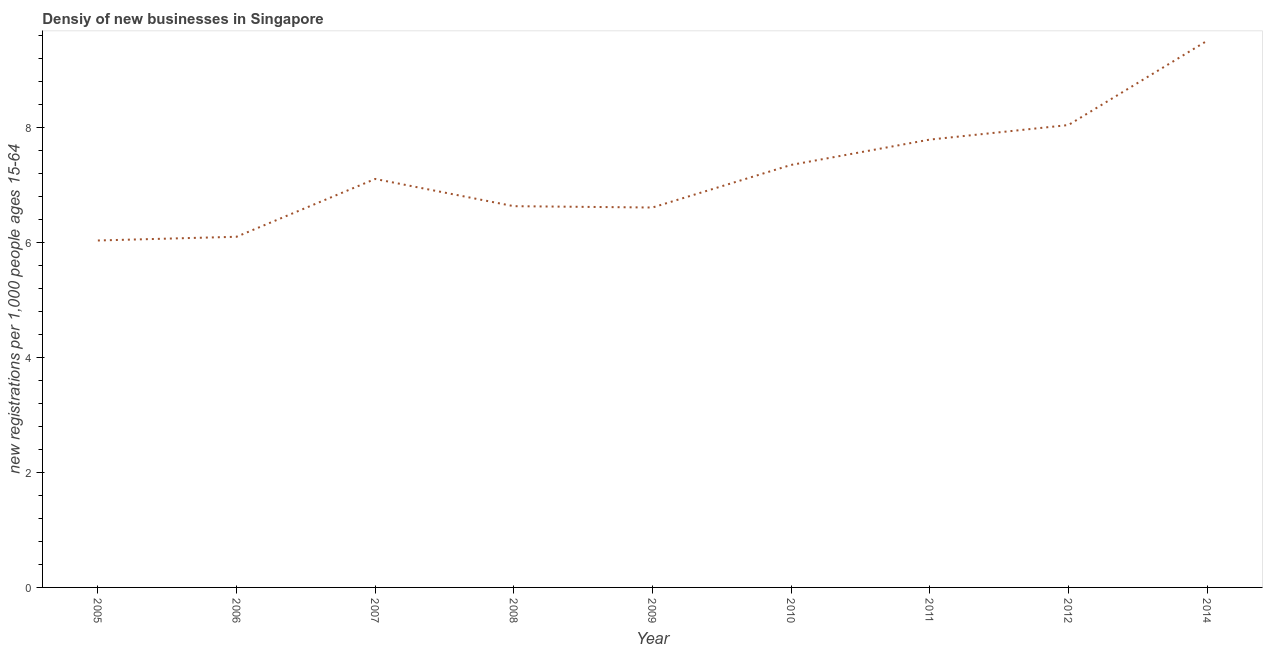What is the density of new business in 2012?
Provide a short and direct response. 8.04. Across all years, what is the maximum density of new business?
Provide a short and direct response. 9.51. Across all years, what is the minimum density of new business?
Offer a very short reply. 6.04. In which year was the density of new business maximum?
Make the answer very short. 2014. In which year was the density of new business minimum?
Your answer should be very brief. 2005. What is the sum of the density of new business?
Your response must be concise. 65.18. What is the difference between the density of new business in 2005 and 2010?
Your response must be concise. -1.31. What is the average density of new business per year?
Provide a short and direct response. 7.24. What is the median density of new business?
Offer a very short reply. 7.11. In how many years, is the density of new business greater than 4.4 ?
Your response must be concise. 9. What is the ratio of the density of new business in 2005 to that in 2009?
Offer a terse response. 0.91. What is the difference between the highest and the second highest density of new business?
Your answer should be very brief. 1.47. Is the sum of the density of new business in 2005 and 2006 greater than the maximum density of new business across all years?
Provide a short and direct response. Yes. What is the difference between the highest and the lowest density of new business?
Offer a terse response. 3.47. Does the density of new business monotonically increase over the years?
Make the answer very short. No. What is the title of the graph?
Give a very brief answer. Densiy of new businesses in Singapore. What is the label or title of the X-axis?
Make the answer very short. Year. What is the label or title of the Y-axis?
Ensure brevity in your answer.  New registrations per 1,0 people ages 15-64. What is the new registrations per 1,000 people ages 15-64 in 2005?
Make the answer very short. 6.04. What is the new registrations per 1,000 people ages 15-64 of 2006?
Offer a terse response. 6.1. What is the new registrations per 1,000 people ages 15-64 of 2007?
Make the answer very short. 7.11. What is the new registrations per 1,000 people ages 15-64 of 2008?
Offer a terse response. 6.63. What is the new registrations per 1,000 people ages 15-64 in 2009?
Your answer should be compact. 6.61. What is the new registrations per 1,000 people ages 15-64 of 2010?
Your answer should be compact. 7.35. What is the new registrations per 1,000 people ages 15-64 in 2011?
Make the answer very short. 7.79. What is the new registrations per 1,000 people ages 15-64 of 2012?
Provide a short and direct response. 8.04. What is the new registrations per 1,000 people ages 15-64 of 2014?
Offer a very short reply. 9.51. What is the difference between the new registrations per 1,000 people ages 15-64 in 2005 and 2006?
Your answer should be very brief. -0.06. What is the difference between the new registrations per 1,000 people ages 15-64 in 2005 and 2007?
Your response must be concise. -1.07. What is the difference between the new registrations per 1,000 people ages 15-64 in 2005 and 2008?
Provide a succinct answer. -0.6. What is the difference between the new registrations per 1,000 people ages 15-64 in 2005 and 2009?
Offer a terse response. -0.57. What is the difference between the new registrations per 1,000 people ages 15-64 in 2005 and 2010?
Give a very brief answer. -1.31. What is the difference between the new registrations per 1,000 people ages 15-64 in 2005 and 2011?
Your answer should be compact. -1.76. What is the difference between the new registrations per 1,000 people ages 15-64 in 2005 and 2012?
Offer a terse response. -2.01. What is the difference between the new registrations per 1,000 people ages 15-64 in 2005 and 2014?
Your answer should be very brief. -3.47. What is the difference between the new registrations per 1,000 people ages 15-64 in 2006 and 2007?
Your answer should be very brief. -1.01. What is the difference between the new registrations per 1,000 people ages 15-64 in 2006 and 2008?
Provide a succinct answer. -0.53. What is the difference between the new registrations per 1,000 people ages 15-64 in 2006 and 2009?
Your response must be concise. -0.51. What is the difference between the new registrations per 1,000 people ages 15-64 in 2006 and 2010?
Offer a terse response. -1.25. What is the difference between the new registrations per 1,000 people ages 15-64 in 2006 and 2011?
Keep it short and to the point. -1.69. What is the difference between the new registrations per 1,000 people ages 15-64 in 2006 and 2012?
Provide a short and direct response. -1.94. What is the difference between the new registrations per 1,000 people ages 15-64 in 2006 and 2014?
Offer a very short reply. -3.41. What is the difference between the new registrations per 1,000 people ages 15-64 in 2007 and 2008?
Provide a short and direct response. 0.47. What is the difference between the new registrations per 1,000 people ages 15-64 in 2007 and 2009?
Provide a short and direct response. 0.5. What is the difference between the new registrations per 1,000 people ages 15-64 in 2007 and 2010?
Give a very brief answer. -0.24. What is the difference between the new registrations per 1,000 people ages 15-64 in 2007 and 2011?
Ensure brevity in your answer.  -0.68. What is the difference between the new registrations per 1,000 people ages 15-64 in 2007 and 2012?
Offer a terse response. -0.94. What is the difference between the new registrations per 1,000 people ages 15-64 in 2007 and 2014?
Provide a succinct answer. -2.4. What is the difference between the new registrations per 1,000 people ages 15-64 in 2008 and 2009?
Make the answer very short. 0.02. What is the difference between the new registrations per 1,000 people ages 15-64 in 2008 and 2010?
Offer a very short reply. -0.72. What is the difference between the new registrations per 1,000 people ages 15-64 in 2008 and 2011?
Make the answer very short. -1.16. What is the difference between the new registrations per 1,000 people ages 15-64 in 2008 and 2012?
Your answer should be very brief. -1.41. What is the difference between the new registrations per 1,000 people ages 15-64 in 2008 and 2014?
Provide a short and direct response. -2.88. What is the difference between the new registrations per 1,000 people ages 15-64 in 2009 and 2010?
Offer a very short reply. -0.74. What is the difference between the new registrations per 1,000 people ages 15-64 in 2009 and 2011?
Offer a terse response. -1.18. What is the difference between the new registrations per 1,000 people ages 15-64 in 2009 and 2012?
Your answer should be very brief. -1.44. What is the difference between the new registrations per 1,000 people ages 15-64 in 2009 and 2014?
Make the answer very short. -2.9. What is the difference between the new registrations per 1,000 people ages 15-64 in 2010 and 2011?
Provide a short and direct response. -0.44. What is the difference between the new registrations per 1,000 people ages 15-64 in 2010 and 2012?
Your answer should be very brief. -0.69. What is the difference between the new registrations per 1,000 people ages 15-64 in 2010 and 2014?
Offer a very short reply. -2.16. What is the difference between the new registrations per 1,000 people ages 15-64 in 2011 and 2012?
Give a very brief answer. -0.25. What is the difference between the new registrations per 1,000 people ages 15-64 in 2011 and 2014?
Your response must be concise. -1.72. What is the difference between the new registrations per 1,000 people ages 15-64 in 2012 and 2014?
Offer a terse response. -1.47. What is the ratio of the new registrations per 1,000 people ages 15-64 in 2005 to that in 2006?
Ensure brevity in your answer.  0.99. What is the ratio of the new registrations per 1,000 people ages 15-64 in 2005 to that in 2007?
Your response must be concise. 0.85. What is the ratio of the new registrations per 1,000 people ages 15-64 in 2005 to that in 2008?
Offer a terse response. 0.91. What is the ratio of the new registrations per 1,000 people ages 15-64 in 2005 to that in 2010?
Offer a terse response. 0.82. What is the ratio of the new registrations per 1,000 people ages 15-64 in 2005 to that in 2011?
Offer a terse response. 0.78. What is the ratio of the new registrations per 1,000 people ages 15-64 in 2005 to that in 2012?
Your answer should be compact. 0.75. What is the ratio of the new registrations per 1,000 people ages 15-64 in 2005 to that in 2014?
Make the answer very short. 0.64. What is the ratio of the new registrations per 1,000 people ages 15-64 in 2006 to that in 2007?
Your response must be concise. 0.86. What is the ratio of the new registrations per 1,000 people ages 15-64 in 2006 to that in 2008?
Make the answer very short. 0.92. What is the ratio of the new registrations per 1,000 people ages 15-64 in 2006 to that in 2009?
Offer a very short reply. 0.92. What is the ratio of the new registrations per 1,000 people ages 15-64 in 2006 to that in 2010?
Offer a terse response. 0.83. What is the ratio of the new registrations per 1,000 people ages 15-64 in 2006 to that in 2011?
Provide a succinct answer. 0.78. What is the ratio of the new registrations per 1,000 people ages 15-64 in 2006 to that in 2012?
Make the answer very short. 0.76. What is the ratio of the new registrations per 1,000 people ages 15-64 in 2006 to that in 2014?
Keep it short and to the point. 0.64. What is the ratio of the new registrations per 1,000 people ages 15-64 in 2007 to that in 2008?
Offer a terse response. 1.07. What is the ratio of the new registrations per 1,000 people ages 15-64 in 2007 to that in 2009?
Provide a succinct answer. 1.07. What is the ratio of the new registrations per 1,000 people ages 15-64 in 2007 to that in 2011?
Your answer should be very brief. 0.91. What is the ratio of the new registrations per 1,000 people ages 15-64 in 2007 to that in 2012?
Your answer should be compact. 0.88. What is the ratio of the new registrations per 1,000 people ages 15-64 in 2007 to that in 2014?
Offer a very short reply. 0.75. What is the ratio of the new registrations per 1,000 people ages 15-64 in 2008 to that in 2009?
Your answer should be very brief. 1. What is the ratio of the new registrations per 1,000 people ages 15-64 in 2008 to that in 2010?
Make the answer very short. 0.9. What is the ratio of the new registrations per 1,000 people ages 15-64 in 2008 to that in 2011?
Provide a succinct answer. 0.85. What is the ratio of the new registrations per 1,000 people ages 15-64 in 2008 to that in 2012?
Your answer should be compact. 0.82. What is the ratio of the new registrations per 1,000 people ages 15-64 in 2008 to that in 2014?
Keep it short and to the point. 0.7. What is the ratio of the new registrations per 1,000 people ages 15-64 in 2009 to that in 2010?
Provide a succinct answer. 0.9. What is the ratio of the new registrations per 1,000 people ages 15-64 in 2009 to that in 2011?
Offer a terse response. 0.85. What is the ratio of the new registrations per 1,000 people ages 15-64 in 2009 to that in 2012?
Provide a short and direct response. 0.82. What is the ratio of the new registrations per 1,000 people ages 15-64 in 2009 to that in 2014?
Make the answer very short. 0.69. What is the ratio of the new registrations per 1,000 people ages 15-64 in 2010 to that in 2011?
Provide a short and direct response. 0.94. What is the ratio of the new registrations per 1,000 people ages 15-64 in 2010 to that in 2012?
Provide a succinct answer. 0.91. What is the ratio of the new registrations per 1,000 people ages 15-64 in 2010 to that in 2014?
Provide a short and direct response. 0.77. What is the ratio of the new registrations per 1,000 people ages 15-64 in 2011 to that in 2012?
Keep it short and to the point. 0.97. What is the ratio of the new registrations per 1,000 people ages 15-64 in 2011 to that in 2014?
Offer a very short reply. 0.82. What is the ratio of the new registrations per 1,000 people ages 15-64 in 2012 to that in 2014?
Offer a terse response. 0.85. 